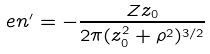<formula> <loc_0><loc_0><loc_500><loc_500>e n ^ { \prime } = - \frac { Z z _ { 0 } } { 2 \pi ( z _ { 0 } ^ { 2 } + \rho ^ { 2 } ) ^ { 3 / 2 } }</formula> 